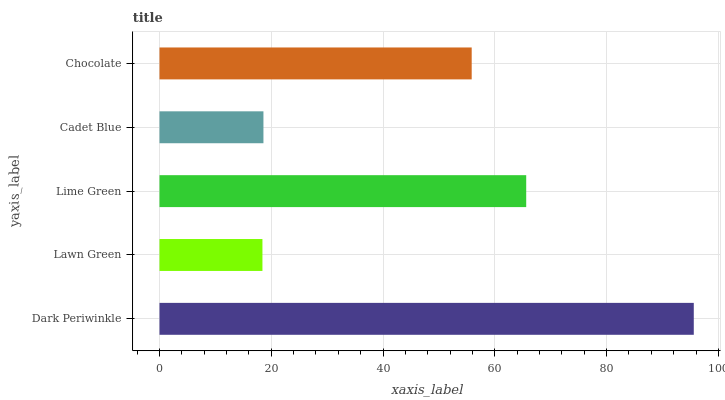Is Lawn Green the minimum?
Answer yes or no. Yes. Is Dark Periwinkle the maximum?
Answer yes or no. Yes. Is Lime Green the minimum?
Answer yes or no. No. Is Lime Green the maximum?
Answer yes or no. No. Is Lime Green greater than Lawn Green?
Answer yes or no. Yes. Is Lawn Green less than Lime Green?
Answer yes or no. Yes. Is Lawn Green greater than Lime Green?
Answer yes or no. No. Is Lime Green less than Lawn Green?
Answer yes or no. No. Is Chocolate the high median?
Answer yes or no. Yes. Is Chocolate the low median?
Answer yes or no. Yes. Is Lawn Green the high median?
Answer yes or no. No. Is Dark Periwinkle the low median?
Answer yes or no. No. 